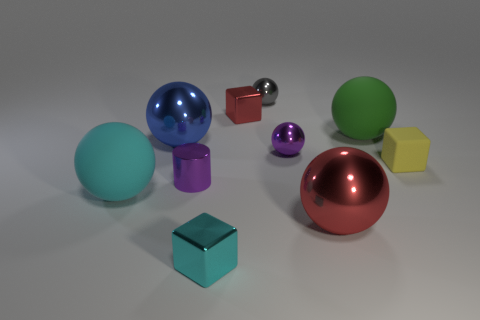There is a small metal object that is in front of the cyan object on the left side of the small purple shiny cylinder; what is its shape?
Provide a succinct answer. Cube. Are there any other things of the same color as the tiny matte object?
Provide a short and direct response. No. Does the rubber block have the same color as the tiny shiny cylinder?
Keep it short and to the point. No. How many red objects are tiny matte cubes or cubes?
Your answer should be very brief. 1. Is the number of blue metal objects behind the red cube less than the number of brown rubber cylinders?
Keep it short and to the point. No. What number of tiny objects are on the right side of the tiny purple thing in front of the rubber block?
Give a very brief answer. 5. How many other things are there of the same size as the cyan metallic block?
Make the answer very short. 5. What number of objects are either big green objects or big objects on the right side of the large red metal thing?
Offer a terse response. 1. Is the number of big yellow matte cubes less than the number of large matte spheres?
Your response must be concise. Yes. What color is the big metallic sphere left of the small purple thing that is in front of the tiny rubber block?
Make the answer very short. Blue. 